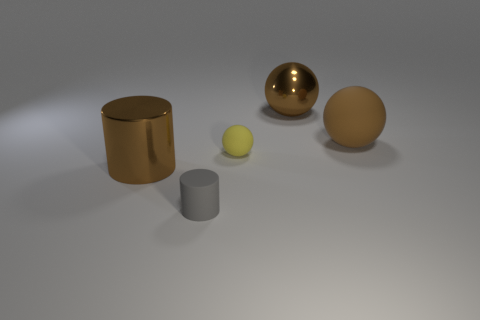Subtract all big brown balls. How many balls are left? 1 Add 5 small spheres. How many objects exist? 10 Subtract all balls. How many objects are left? 2 Subtract all brown matte spheres. Subtract all brown balls. How many objects are left? 2 Add 5 gray rubber objects. How many gray rubber objects are left? 6 Add 3 small green matte spheres. How many small green matte spheres exist? 3 Subtract 0 green cylinders. How many objects are left? 5 Subtract all red spheres. Subtract all red cylinders. How many spheres are left? 3 